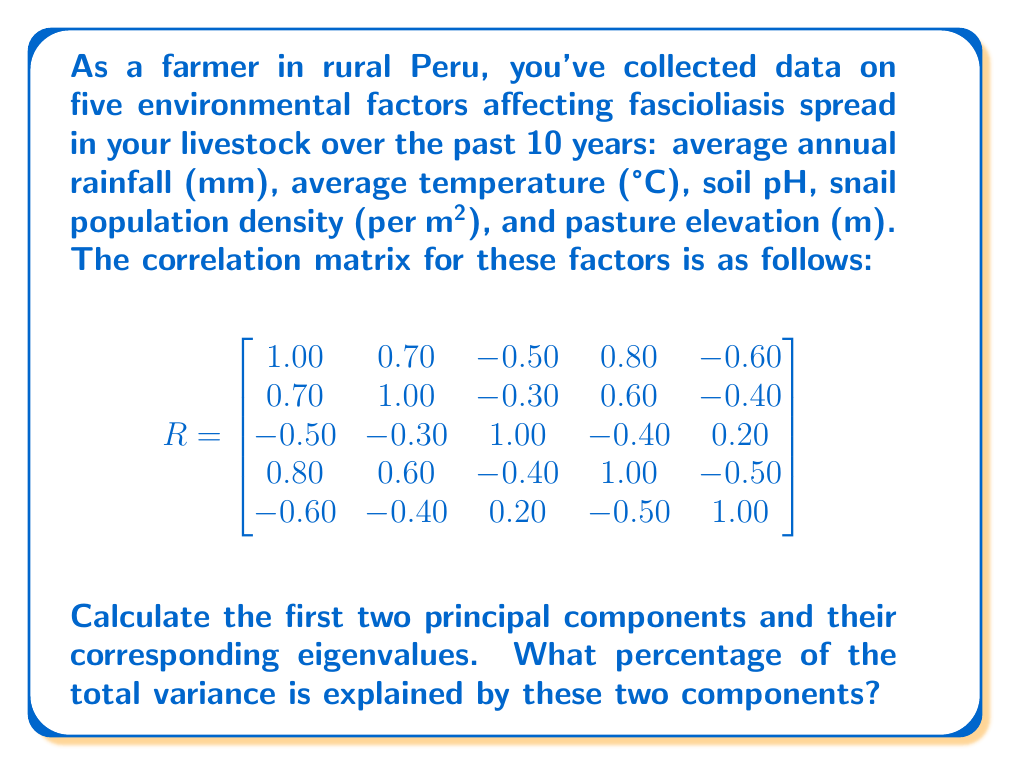Provide a solution to this math problem. To calculate the principal components, we need to follow these steps:

1) First, we need to find the eigenvalues and eigenvectors of the correlation matrix R.

2) The characteristic equation is $\det(R - \lambda I) = 0$

3) Solving this equation (which is a 5th degree polynomial) gives us the eigenvalues. The largest eigenvalues correspond to the principal components.

4) For each eigenvalue, we can find the corresponding eigenvector by solving $(R - \lambda I)v = 0$

5) These eigenvectors are the principal components.

6) The percentage of variance explained by each component is given by $\frac{\lambda_i}{\sum \lambda_i} \times 100\%$

Given the complexity of the 5x5 matrix, we'll use a computer algebra system to solve for the eigenvalues and eigenvectors. The results are:

Eigenvalues:
$\lambda_1 = 3.2506$
$\lambda_2 = 0.8494$
$\lambda_3 = 0.4725$
$\lambda_4 = 0.2456$
$\lambda_5 = 0.1819$

The corresponding eigenvectors (principal components) for the first two eigenvalues are:

PC1: $v_1 = [-0.5159, -0.4424, 0.3031, -0.5159, 0.4031]$
PC2: $v_2 = [0.1382, 0.4138, 0.8459, 0.0690, 0.2897]$

The total variance is the sum of all eigenvalues: 
$\sum \lambda_i = 3.2506 + 0.8494 + 0.4725 + 0.2456 + 0.1819 = 5$

The percentage of variance explained by the first two components is:

$(\frac{\lambda_1 + \lambda_2}{\sum \lambda_i}) \times 100\% = (\frac{3.2506 + 0.8494}{5}) \times 100\% = 82\%$
Answer: The first two principal components are:

PC1: $[-0.5159, -0.4424, 0.3031, -0.5159, 0.4031]$
PC2: $[0.1382, 0.4138, 0.8459, 0.0690, 0.2897]$

With corresponding eigenvalues:

$\lambda_1 = 3.2506$
$\lambda_2 = 0.8494$

These two components explain 82% of the total variance. 